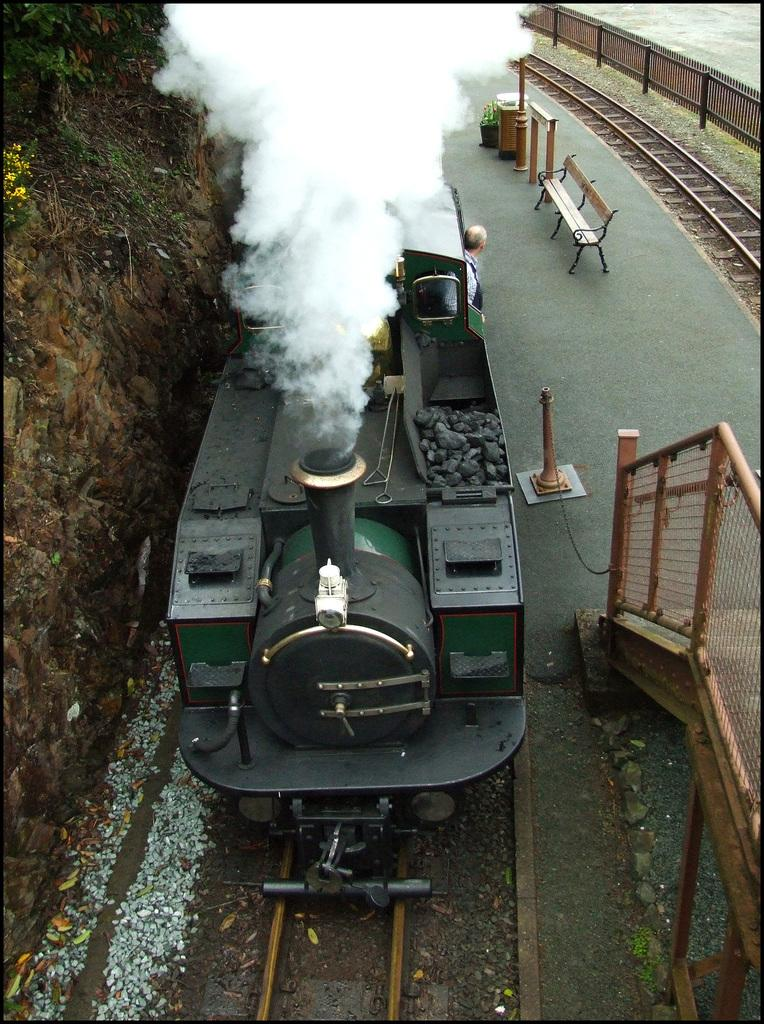What type of structure can be seen in the image? There are stairs in the image. What mode of transportation is present in the image? There is a train in the image. What is the result of the train's movement in the image? There is smoke visible in the image. What type of seating is available in the image? There is a bench in the image. What is the train traveling on in the image? There is a railway track in the image. Can you tell me how many people are sitting at the table in the image? There is no table present in the image; it features stairs, a train, smoke, a bench, and a railway track. What emotion is the group of people feeling in the image? There is no group of people present in the image, and therefore no emotion can be determined. 